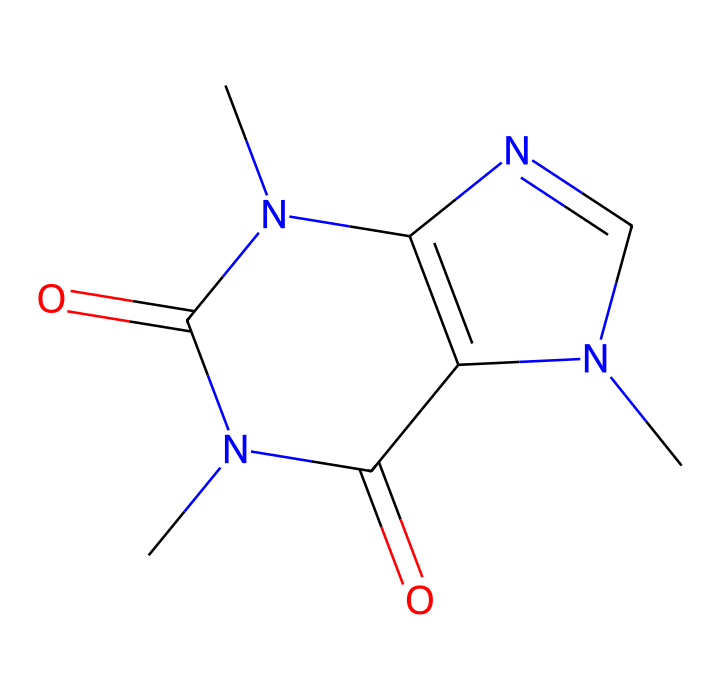What is the molecular formula of caffeine? By analyzing the chemical structure represented by the SMILES, we can count the number of each type of atom present. The structure contains 8 carbon (C) atoms, 10 hydrogen (H) atoms, 4 nitrogen (N) atoms, and 2 oxygen (O) atoms, leading to the molecular formula C8H10N4O2.
Answer: C8H10N4O2 How many nitrogen atoms are present in caffeine? From the chemical structure, we can identify the nitrogen atoms visually or count them based on the SMILES notation. There are 4 nitrogen (N) atoms present in the structure of caffeine.
Answer: 4 How many rings are in caffeine's structure? The structure includes two fused rings, which can be visualized in the chemical representation. Counting the closed loops (rings) shows there are two distinct rings in the structure of caffeine.
Answer: 2 What type of compound is caffeine classified as? The presence of nitrogen atoms in the structure and its role in biological systems allows us to classify caffeine as an alkaloid.
Answer: alkaloid What is the role of caffeine in cognitive function? Caffeine acts as a central nervous system stimulant, enhancing alertness and reducing fatigue through its interaction with adenosine receptors in the brain.
Answer: stimulant Is caffeine considered water-soluble? Caffeine's structure shows multiple polar functional groups, primarily due to the nitrogen and oxygen atoms, which indicates it is generally soluble in water.
Answer: yes 